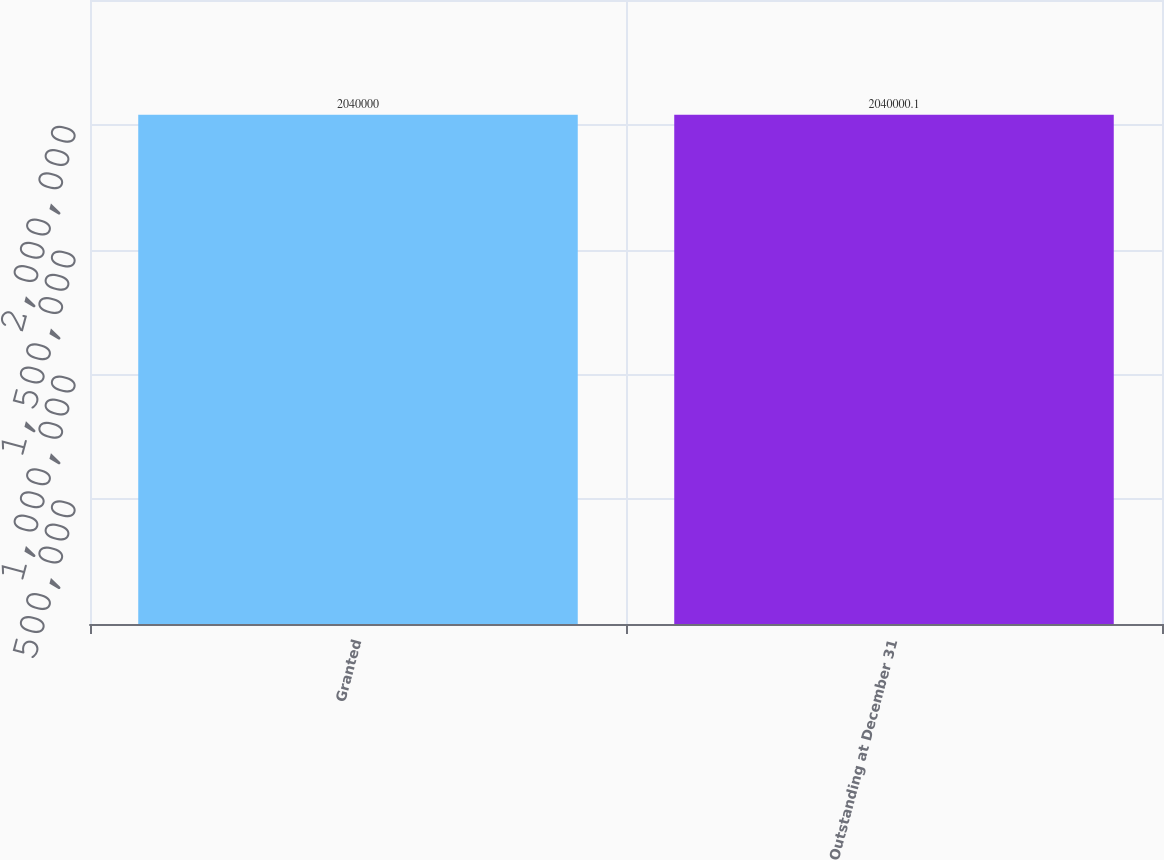Convert chart. <chart><loc_0><loc_0><loc_500><loc_500><bar_chart><fcel>Granted<fcel>Outstanding at December 31<nl><fcel>2.04e+06<fcel>2.04e+06<nl></chart> 